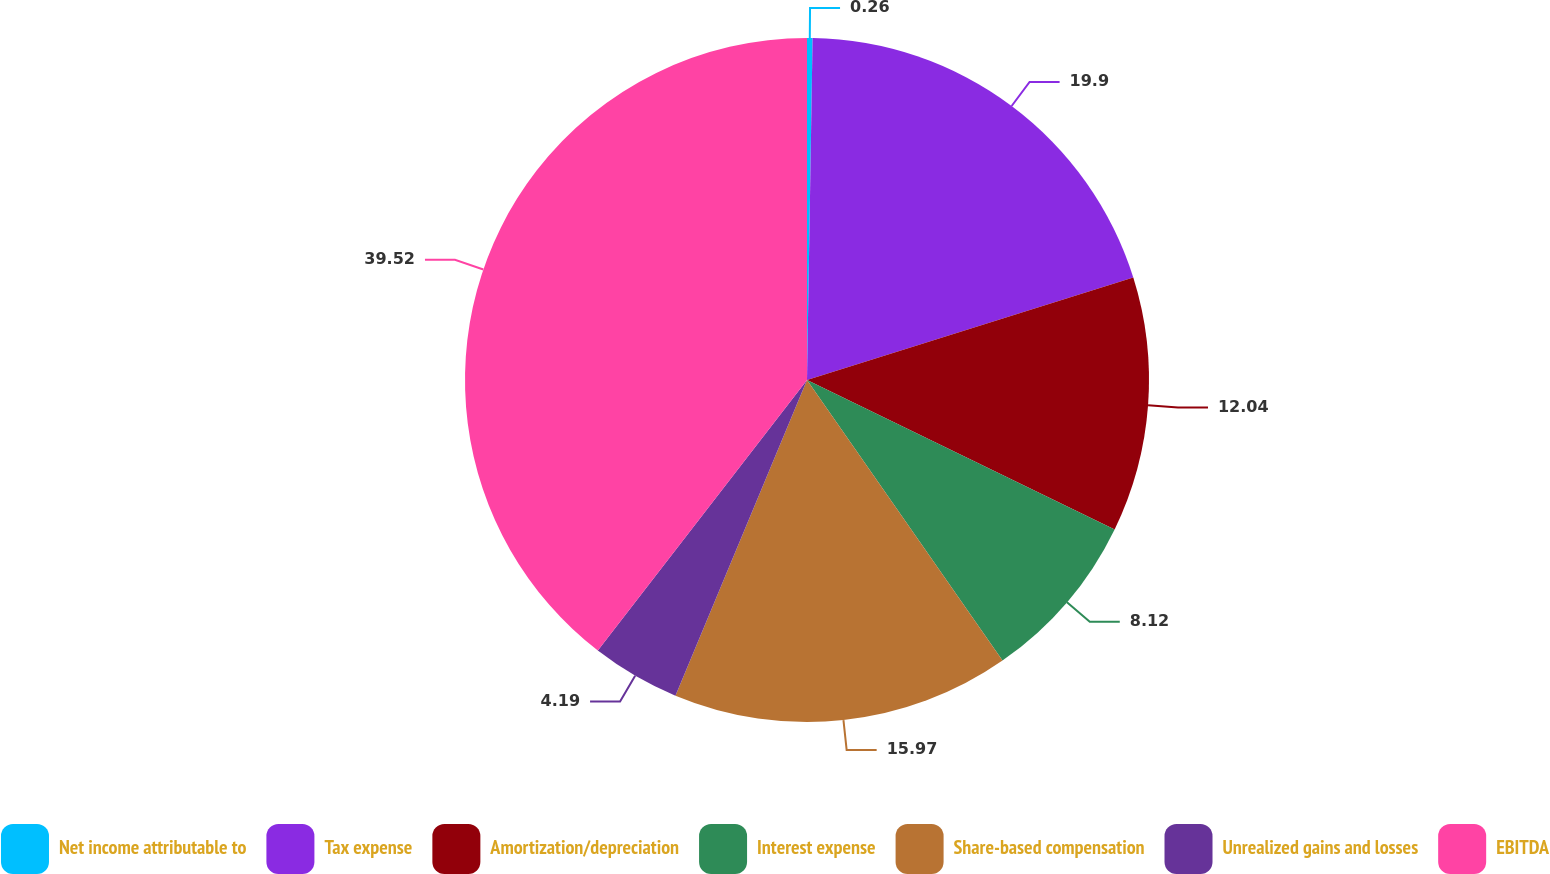<chart> <loc_0><loc_0><loc_500><loc_500><pie_chart><fcel>Net income attributable to<fcel>Tax expense<fcel>Amortization/depreciation<fcel>Interest expense<fcel>Share-based compensation<fcel>Unrealized gains and losses<fcel>EBITDA<nl><fcel>0.26%<fcel>19.9%<fcel>12.04%<fcel>8.12%<fcel>15.97%<fcel>4.19%<fcel>39.53%<nl></chart> 